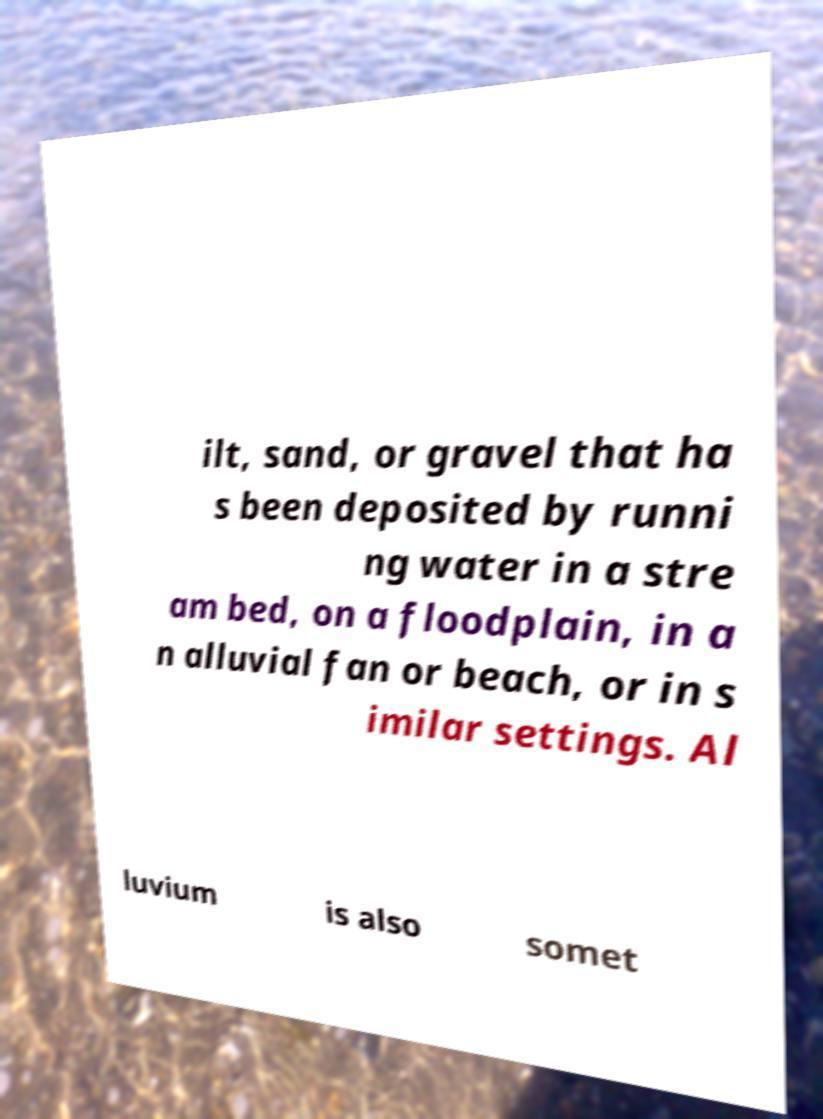What messages or text are displayed in this image? I need them in a readable, typed format. ilt, sand, or gravel that ha s been deposited by runni ng water in a stre am bed, on a floodplain, in a n alluvial fan or beach, or in s imilar settings. Al luvium is also somet 